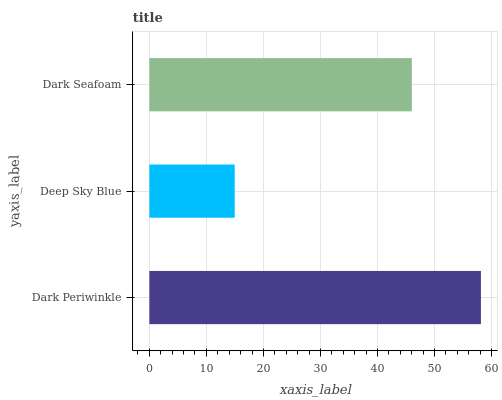Is Deep Sky Blue the minimum?
Answer yes or no. Yes. Is Dark Periwinkle the maximum?
Answer yes or no. Yes. Is Dark Seafoam the minimum?
Answer yes or no. No. Is Dark Seafoam the maximum?
Answer yes or no. No. Is Dark Seafoam greater than Deep Sky Blue?
Answer yes or no. Yes. Is Deep Sky Blue less than Dark Seafoam?
Answer yes or no. Yes. Is Deep Sky Blue greater than Dark Seafoam?
Answer yes or no. No. Is Dark Seafoam less than Deep Sky Blue?
Answer yes or no. No. Is Dark Seafoam the high median?
Answer yes or no. Yes. Is Dark Seafoam the low median?
Answer yes or no. Yes. Is Dark Periwinkle the high median?
Answer yes or no. No. Is Dark Periwinkle the low median?
Answer yes or no. No. 